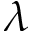<formula> <loc_0><loc_0><loc_500><loc_500>\lambda</formula> 